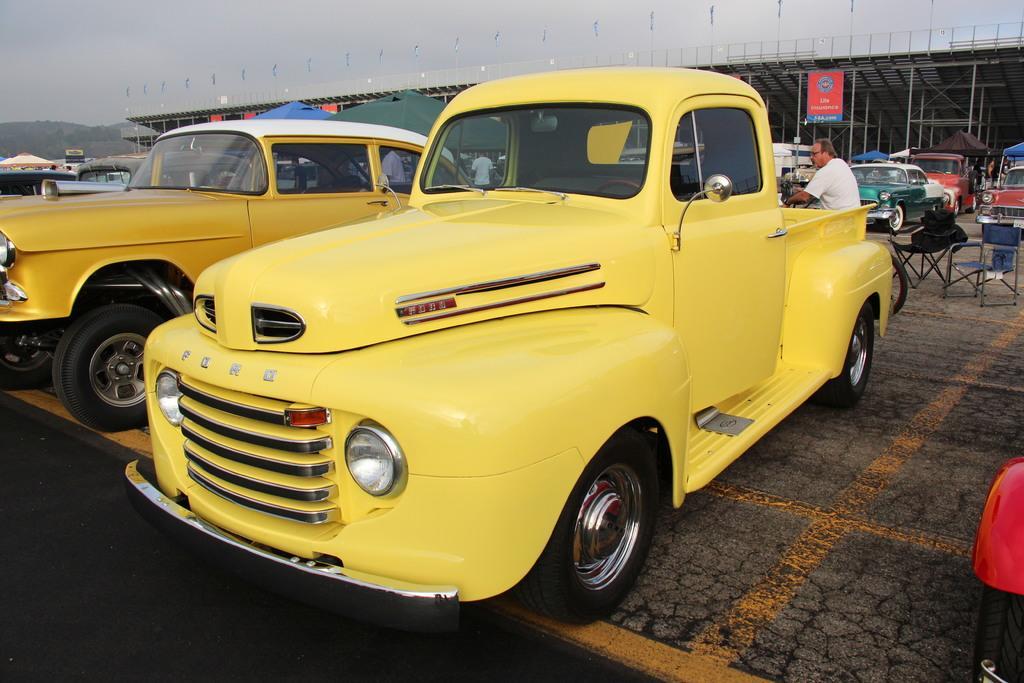Can you describe this image briefly? In this image in the center there are cars, and in the background there are some people cars and there is a shed, poles, boards, chairs and some objects and there are mountains. At the top there is sky, and at the bottom there is floor and on the right side of the image there is one vehicle tyre is visible. 